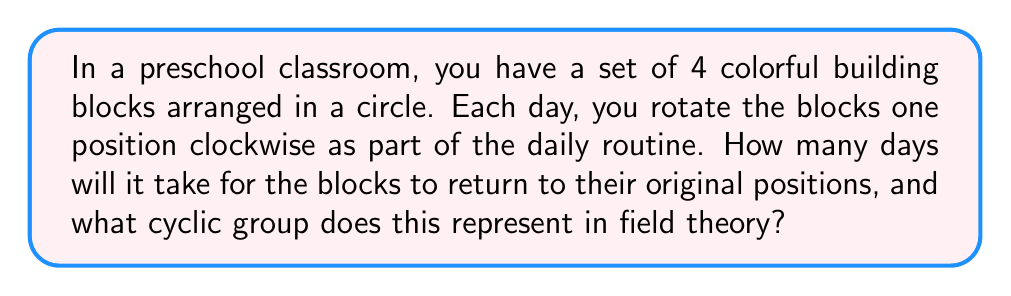Teach me how to tackle this problem. Let's approach this step-by-step:

1) First, we need to understand what's happening:
   - We have 4 blocks in a circle
   - Each day, we rotate them once clockwise

2) This forms a cyclic group. Let's call the initial arrangement $e$ (identity), and each rotation $r$. So we have:
   
   $e$ (initial position)
   $r$ (after 1 rotation)
   $r^2$ (after 2 rotations)
   $r^3$ (after 3 rotations)

3) After 4 rotations, we're back to the initial position:

   $r^4 = e$

4) This forms a cyclic group of order 4, which we can denote as $C_4$ or $\mathbb{Z}/4\mathbb{Z}$.

5) In field theory, this group is isomorphic to the additive group of the field $\mathbb{F}_4$ (the finite field with 4 elements).

6) The properties of this cyclic group include:
   - Closure: Rotating any number of times always results in a valid arrangement
   - Associativity: $(r^a r^b) r^c = r^a (r^b r^c)$ for any integers $a$, $b$, $c$
   - Identity: $e$ (no rotation) leaves the arrangement unchanged
   - Inverse: Rotating 3 times clockwise is equivalent to rotating once counterclockwise

7) Therefore, it will take 4 days for the blocks to return to their original positions.
Answer: 4 days; $C_4$ or $\mathbb{Z}/4\mathbb{Z}$ 